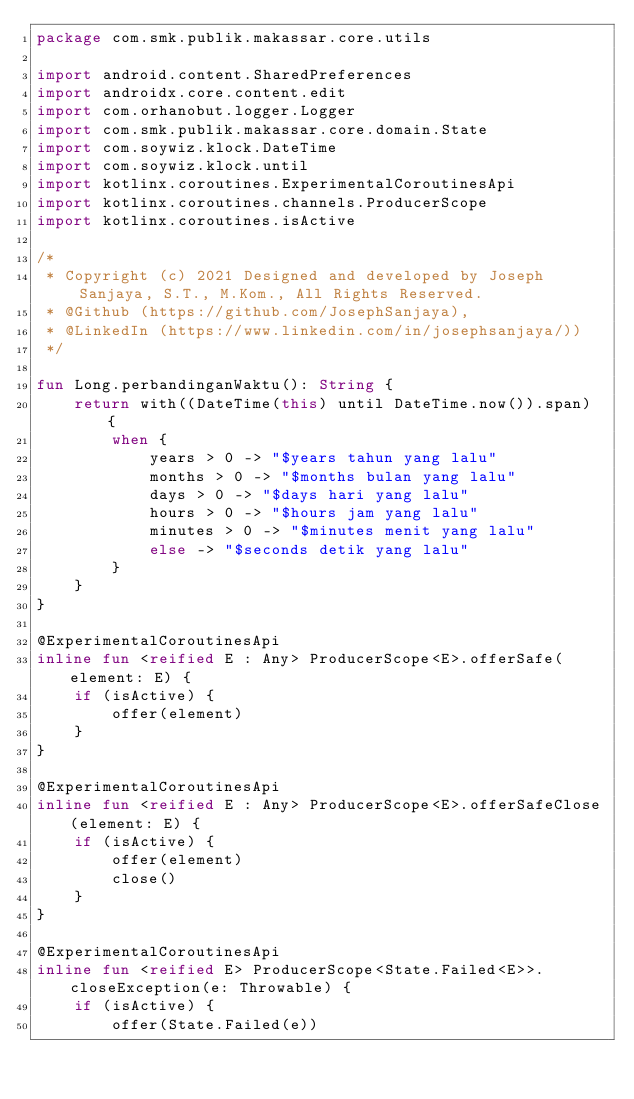Convert code to text. <code><loc_0><loc_0><loc_500><loc_500><_Kotlin_>package com.smk.publik.makassar.core.utils

import android.content.SharedPreferences
import androidx.core.content.edit
import com.orhanobut.logger.Logger
import com.smk.publik.makassar.core.domain.State
import com.soywiz.klock.DateTime
import com.soywiz.klock.until
import kotlinx.coroutines.ExperimentalCoroutinesApi
import kotlinx.coroutines.channels.ProducerScope
import kotlinx.coroutines.isActive

/*
 * Copyright (c) 2021 Designed and developed by Joseph Sanjaya, S.T., M.Kom., All Rights Reserved.
 * @Github (https://github.com/JosephSanjaya),
 * @LinkedIn (https://www.linkedin.com/in/josephsanjaya/))
 */

fun Long.perbandinganWaktu(): String {
    return with((DateTime(this) until DateTime.now()).span) {
        when {
            years > 0 -> "$years tahun yang lalu"
            months > 0 -> "$months bulan yang lalu"
            days > 0 -> "$days hari yang lalu"
            hours > 0 -> "$hours jam yang lalu"
            minutes > 0 -> "$minutes menit yang lalu"
            else -> "$seconds detik yang lalu"
        }
    }
}

@ExperimentalCoroutinesApi
inline fun <reified E : Any> ProducerScope<E>.offerSafe(element: E) {
    if (isActive) {
        offer(element)
    }
}

@ExperimentalCoroutinesApi
inline fun <reified E : Any> ProducerScope<E>.offerSafeClose(element: E) {
    if (isActive) {
        offer(element)
        close()
    }
}

@ExperimentalCoroutinesApi
inline fun <reified E> ProducerScope<State.Failed<E>>.closeException(e: Throwable) {
    if (isActive) {
        offer(State.Failed(e))</code> 